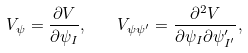<formula> <loc_0><loc_0><loc_500><loc_500>V _ { \psi } = \frac { \partial V } { \partial \psi _ { I } } , \quad V _ { \psi \psi ^ { \prime } } = \frac { \partial ^ { 2 } V } { \partial \psi _ { I } \partial \psi ^ { \prime } _ { I ^ { \prime } } } ,</formula> 